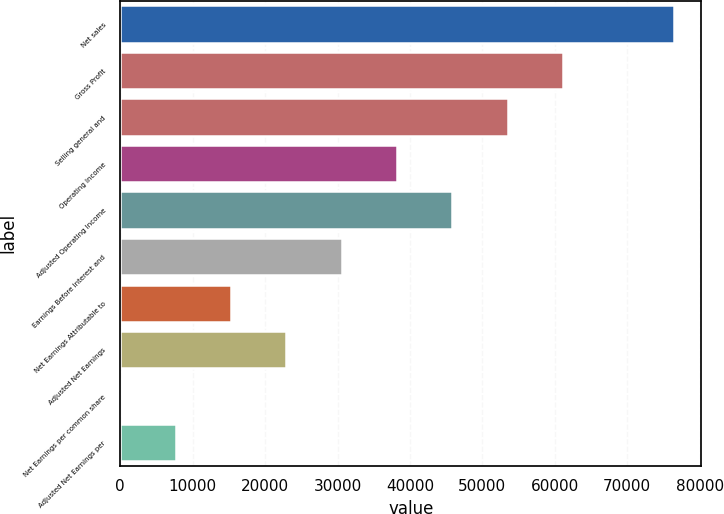Convert chart to OTSL. <chart><loc_0><loc_0><loc_500><loc_500><bar_chart><fcel>Net sales<fcel>Gross Profit<fcel>Selling general and<fcel>Operating Income<fcel>Adjusted Operating Income<fcel>Earnings Before Interest and<fcel>Net Earnings Attributable to<fcel>Adjusted Net Earnings<fcel>Net Earnings per common share<fcel>Adjusted Net Earnings per<nl><fcel>76392<fcel>61114<fcel>53475<fcel>38197<fcel>45836<fcel>30558<fcel>15280<fcel>22919<fcel>2<fcel>7641<nl></chart> 